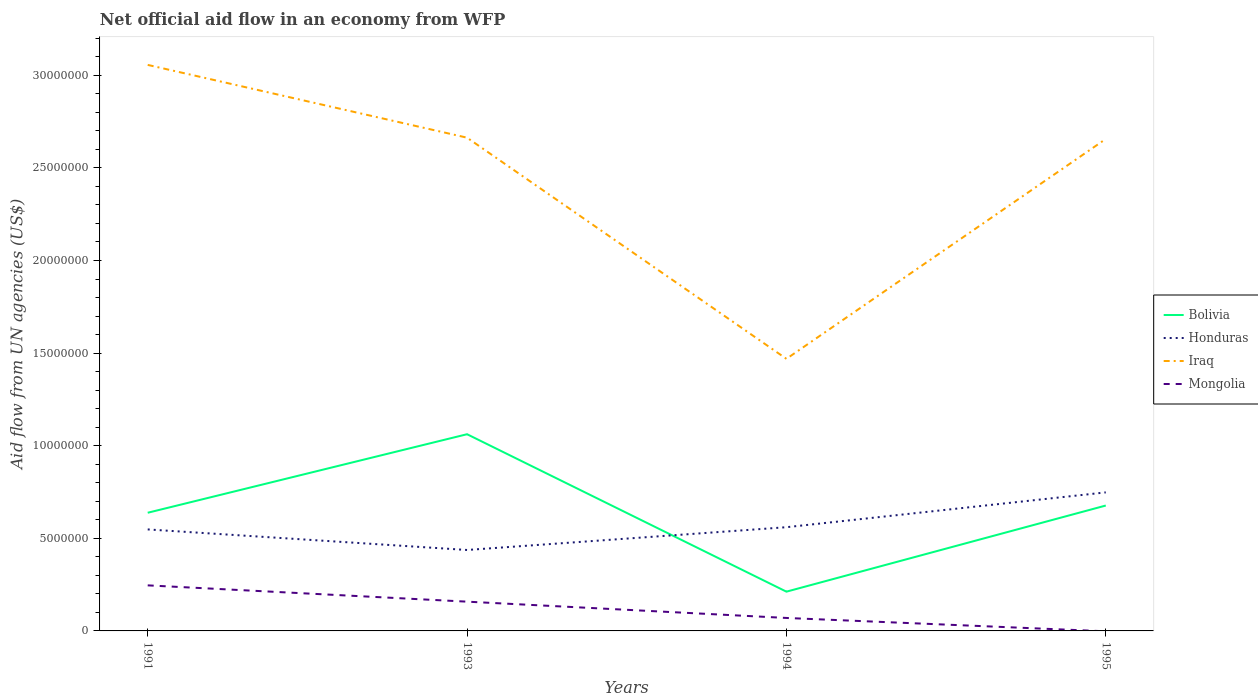Is the number of lines equal to the number of legend labels?
Make the answer very short. No. Across all years, what is the maximum net official aid flow in Iraq?
Ensure brevity in your answer.  1.47e+07. What is the total net official aid flow in Bolivia in the graph?
Provide a short and direct response. -4.24e+06. What is the difference between the highest and the second highest net official aid flow in Honduras?
Give a very brief answer. 3.11e+06. What is the difference between the highest and the lowest net official aid flow in Bolivia?
Ensure brevity in your answer.  2. What is the difference between two consecutive major ticks on the Y-axis?
Offer a terse response. 5.00e+06. Are the values on the major ticks of Y-axis written in scientific E-notation?
Keep it short and to the point. No. Does the graph contain grids?
Your response must be concise. No. How many legend labels are there?
Your answer should be compact. 4. What is the title of the graph?
Make the answer very short. Net official aid flow in an economy from WFP. What is the label or title of the Y-axis?
Make the answer very short. Aid flow from UN agencies (US$). What is the Aid flow from UN agencies (US$) in Bolivia in 1991?
Offer a terse response. 6.38e+06. What is the Aid flow from UN agencies (US$) in Honduras in 1991?
Provide a short and direct response. 5.48e+06. What is the Aid flow from UN agencies (US$) in Iraq in 1991?
Make the answer very short. 3.06e+07. What is the Aid flow from UN agencies (US$) of Mongolia in 1991?
Provide a short and direct response. 2.46e+06. What is the Aid flow from UN agencies (US$) in Bolivia in 1993?
Your answer should be compact. 1.06e+07. What is the Aid flow from UN agencies (US$) of Honduras in 1993?
Make the answer very short. 4.37e+06. What is the Aid flow from UN agencies (US$) in Iraq in 1993?
Give a very brief answer. 2.66e+07. What is the Aid flow from UN agencies (US$) of Mongolia in 1993?
Provide a short and direct response. 1.58e+06. What is the Aid flow from UN agencies (US$) in Bolivia in 1994?
Your answer should be compact. 2.12e+06. What is the Aid flow from UN agencies (US$) of Honduras in 1994?
Offer a terse response. 5.60e+06. What is the Aid flow from UN agencies (US$) of Iraq in 1994?
Ensure brevity in your answer.  1.47e+07. What is the Aid flow from UN agencies (US$) in Bolivia in 1995?
Provide a short and direct response. 6.77e+06. What is the Aid flow from UN agencies (US$) of Honduras in 1995?
Provide a succinct answer. 7.48e+06. What is the Aid flow from UN agencies (US$) in Iraq in 1995?
Your response must be concise. 2.66e+07. What is the Aid flow from UN agencies (US$) of Mongolia in 1995?
Offer a very short reply. 0. Across all years, what is the maximum Aid flow from UN agencies (US$) in Bolivia?
Your response must be concise. 1.06e+07. Across all years, what is the maximum Aid flow from UN agencies (US$) of Honduras?
Offer a terse response. 7.48e+06. Across all years, what is the maximum Aid flow from UN agencies (US$) of Iraq?
Ensure brevity in your answer.  3.06e+07. Across all years, what is the maximum Aid flow from UN agencies (US$) of Mongolia?
Offer a terse response. 2.46e+06. Across all years, what is the minimum Aid flow from UN agencies (US$) of Bolivia?
Your answer should be compact. 2.12e+06. Across all years, what is the minimum Aid flow from UN agencies (US$) of Honduras?
Provide a short and direct response. 4.37e+06. Across all years, what is the minimum Aid flow from UN agencies (US$) of Iraq?
Provide a short and direct response. 1.47e+07. Across all years, what is the minimum Aid flow from UN agencies (US$) of Mongolia?
Keep it short and to the point. 0. What is the total Aid flow from UN agencies (US$) in Bolivia in the graph?
Offer a very short reply. 2.59e+07. What is the total Aid flow from UN agencies (US$) in Honduras in the graph?
Provide a short and direct response. 2.29e+07. What is the total Aid flow from UN agencies (US$) in Iraq in the graph?
Provide a short and direct response. 9.84e+07. What is the total Aid flow from UN agencies (US$) of Mongolia in the graph?
Offer a very short reply. 4.74e+06. What is the difference between the Aid flow from UN agencies (US$) of Bolivia in 1991 and that in 1993?
Keep it short and to the point. -4.24e+06. What is the difference between the Aid flow from UN agencies (US$) of Honduras in 1991 and that in 1993?
Offer a terse response. 1.11e+06. What is the difference between the Aid flow from UN agencies (US$) of Iraq in 1991 and that in 1993?
Your response must be concise. 3.93e+06. What is the difference between the Aid flow from UN agencies (US$) in Mongolia in 1991 and that in 1993?
Make the answer very short. 8.80e+05. What is the difference between the Aid flow from UN agencies (US$) of Bolivia in 1991 and that in 1994?
Your answer should be compact. 4.26e+06. What is the difference between the Aid flow from UN agencies (US$) of Honduras in 1991 and that in 1994?
Your answer should be compact. -1.20e+05. What is the difference between the Aid flow from UN agencies (US$) of Iraq in 1991 and that in 1994?
Ensure brevity in your answer.  1.59e+07. What is the difference between the Aid flow from UN agencies (US$) in Mongolia in 1991 and that in 1994?
Offer a very short reply. 1.76e+06. What is the difference between the Aid flow from UN agencies (US$) of Bolivia in 1991 and that in 1995?
Your answer should be very brief. -3.90e+05. What is the difference between the Aid flow from UN agencies (US$) in Honduras in 1991 and that in 1995?
Provide a short and direct response. -2.00e+06. What is the difference between the Aid flow from UN agencies (US$) in Iraq in 1991 and that in 1995?
Provide a short and direct response. 4.00e+06. What is the difference between the Aid flow from UN agencies (US$) in Bolivia in 1993 and that in 1994?
Give a very brief answer. 8.50e+06. What is the difference between the Aid flow from UN agencies (US$) of Honduras in 1993 and that in 1994?
Your answer should be compact. -1.23e+06. What is the difference between the Aid flow from UN agencies (US$) in Iraq in 1993 and that in 1994?
Provide a succinct answer. 1.19e+07. What is the difference between the Aid flow from UN agencies (US$) of Mongolia in 1993 and that in 1994?
Make the answer very short. 8.80e+05. What is the difference between the Aid flow from UN agencies (US$) in Bolivia in 1993 and that in 1995?
Make the answer very short. 3.85e+06. What is the difference between the Aid flow from UN agencies (US$) in Honduras in 1993 and that in 1995?
Your response must be concise. -3.11e+06. What is the difference between the Aid flow from UN agencies (US$) of Iraq in 1993 and that in 1995?
Your response must be concise. 7.00e+04. What is the difference between the Aid flow from UN agencies (US$) in Bolivia in 1994 and that in 1995?
Offer a very short reply. -4.65e+06. What is the difference between the Aid flow from UN agencies (US$) of Honduras in 1994 and that in 1995?
Give a very brief answer. -1.88e+06. What is the difference between the Aid flow from UN agencies (US$) in Iraq in 1994 and that in 1995?
Offer a terse response. -1.19e+07. What is the difference between the Aid flow from UN agencies (US$) in Bolivia in 1991 and the Aid flow from UN agencies (US$) in Honduras in 1993?
Provide a succinct answer. 2.01e+06. What is the difference between the Aid flow from UN agencies (US$) in Bolivia in 1991 and the Aid flow from UN agencies (US$) in Iraq in 1993?
Provide a short and direct response. -2.02e+07. What is the difference between the Aid flow from UN agencies (US$) of Bolivia in 1991 and the Aid flow from UN agencies (US$) of Mongolia in 1993?
Offer a terse response. 4.80e+06. What is the difference between the Aid flow from UN agencies (US$) of Honduras in 1991 and the Aid flow from UN agencies (US$) of Iraq in 1993?
Your response must be concise. -2.12e+07. What is the difference between the Aid flow from UN agencies (US$) of Honduras in 1991 and the Aid flow from UN agencies (US$) of Mongolia in 1993?
Offer a very short reply. 3.90e+06. What is the difference between the Aid flow from UN agencies (US$) in Iraq in 1991 and the Aid flow from UN agencies (US$) in Mongolia in 1993?
Your answer should be compact. 2.90e+07. What is the difference between the Aid flow from UN agencies (US$) in Bolivia in 1991 and the Aid flow from UN agencies (US$) in Honduras in 1994?
Make the answer very short. 7.80e+05. What is the difference between the Aid flow from UN agencies (US$) of Bolivia in 1991 and the Aid flow from UN agencies (US$) of Iraq in 1994?
Provide a succinct answer. -8.31e+06. What is the difference between the Aid flow from UN agencies (US$) of Bolivia in 1991 and the Aid flow from UN agencies (US$) of Mongolia in 1994?
Offer a terse response. 5.68e+06. What is the difference between the Aid flow from UN agencies (US$) in Honduras in 1991 and the Aid flow from UN agencies (US$) in Iraq in 1994?
Offer a very short reply. -9.21e+06. What is the difference between the Aid flow from UN agencies (US$) of Honduras in 1991 and the Aid flow from UN agencies (US$) of Mongolia in 1994?
Offer a very short reply. 4.78e+06. What is the difference between the Aid flow from UN agencies (US$) in Iraq in 1991 and the Aid flow from UN agencies (US$) in Mongolia in 1994?
Ensure brevity in your answer.  2.99e+07. What is the difference between the Aid flow from UN agencies (US$) of Bolivia in 1991 and the Aid flow from UN agencies (US$) of Honduras in 1995?
Offer a very short reply. -1.10e+06. What is the difference between the Aid flow from UN agencies (US$) in Bolivia in 1991 and the Aid flow from UN agencies (US$) in Iraq in 1995?
Keep it short and to the point. -2.02e+07. What is the difference between the Aid flow from UN agencies (US$) in Honduras in 1991 and the Aid flow from UN agencies (US$) in Iraq in 1995?
Your answer should be compact. -2.11e+07. What is the difference between the Aid flow from UN agencies (US$) in Bolivia in 1993 and the Aid flow from UN agencies (US$) in Honduras in 1994?
Offer a very short reply. 5.02e+06. What is the difference between the Aid flow from UN agencies (US$) in Bolivia in 1993 and the Aid flow from UN agencies (US$) in Iraq in 1994?
Make the answer very short. -4.07e+06. What is the difference between the Aid flow from UN agencies (US$) in Bolivia in 1993 and the Aid flow from UN agencies (US$) in Mongolia in 1994?
Ensure brevity in your answer.  9.92e+06. What is the difference between the Aid flow from UN agencies (US$) of Honduras in 1993 and the Aid flow from UN agencies (US$) of Iraq in 1994?
Make the answer very short. -1.03e+07. What is the difference between the Aid flow from UN agencies (US$) in Honduras in 1993 and the Aid flow from UN agencies (US$) in Mongolia in 1994?
Ensure brevity in your answer.  3.67e+06. What is the difference between the Aid flow from UN agencies (US$) in Iraq in 1993 and the Aid flow from UN agencies (US$) in Mongolia in 1994?
Offer a very short reply. 2.59e+07. What is the difference between the Aid flow from UN agencies (US$) in Bolivia in 1993 and the Aid flow from UN agencies (US$) in Honduras in 1995?
Offer a terse response. 3.14e+06. What is the difference between the Aid flow from UN agencies (US$) of Bolivia in 1993 and the Aid flow from UN agencies (US$) of Iraq in 1995?
Offer a very short reply. -1.59e+07. What is the difference between the Aid flow from UN agencies (US$) of Honduras in 1993 and the Aid flow from UN agencies (US$) of Iraq in 1995?
Provide a succinct answer. -2.22e+07. What is the difference between the Aid flow from UN agencies (US$) in Bolivia in 1994 and the Aid flow from UN agencies (US$) in Honduras in 1995?
Ensure brevity in your answer.  -5.36e+06. What is the difference between the Aid flow from UN agencies (US$) in Bolivia in 1994 and the Aid flow from UN agencies (US$) in Iraq in 1995?
Give a very brief answer. -2.44e+07. What is the difference between the Aid flow from UN agencies (US$) in Honduras in 1994 and the Aid flow from UN agencies (US$) in Iraq in 1995?
Make the answer very short. -2.10e+07. What is the average Aid flow from UN agencies (US$) of Bolivia per year?
Offer a very short reply. 6.47e+06. What is the average Aid flow from UN agencies (US$) in Honduras per year?
Provide a succinct answer. 5.73e+06. What is the average Aid flow from UN agencies (US$) of Iraq per year?
Your answer should be compact. 2.46e+07. What is the average Aid flow from UN agencies (US$) in Mongolia per year?
Provide a succinct answer. 1.18e+06. In the year 1991, what is the difference between the Aid flow from UN agencies (US$) of Bolivia and Aid flow from UN agencies (US$) of Honduras?
Make the answer very short. 9.00e+05. In the year 1991, what is the difference between the Aid flow from UN agencies (US$) of Bolivia and Aid flow from UN agencies (US$) of Iraq?
Keep it short and to the point. -2.42e+07. In the year 1991, what is the difference between the Aid flow from UN agencies (US$) of Bolivia and Aid flow from UN agencies (US$) of Mongolia?
Provide a short and direct response. 3.92e+06. In the year 1991, what is the difference between the Aid flow from UN agencies (US$) of Honduras and Aid flow from UN agencies (US$) of Iraq?
Ensure brevity in your answer.  -2.51e+07. In the year 1991, what is the difference between the Aid flow from UN agencies (US$) in Honduras and Aid flow from UN agencies (US$) in Mongolia?
Offer a terse response. 3.02e+06. In the year 1991, what is the difference between the Aid flow from UN agencies (US$) in Iraq and Aid flow from UN agencies (US$) in Mongolia?
Provide a short and direct response. 2.81e+07. In the year 1993, what is the difference between the Aid flow from UN agencies (US$) of Bolivia and Aid flow from UN agencies (US$) of Honduras?
Your answer should be very brief. 6.25e+06. In the year 1993, what is the difference between the Aid flow from UN agencies (US$) of Bolivia and Aid flow from UN agencies (US$) of Iraq?
Provide a short and direct response. -1.60e+07. In the year 1993, what is the difference between the Aid flow from UN agencies (US$) of Bolivia and Aid flow from UN agencies (US$) of Mongolia?
Keep it short and to the point. 9.04e+06. In the year 1993, what is the difference between the Aid flow from UN agencies (US$) in Honduras and Aid flow from UN agencies (US$) in Iraq?
Provide a short and direct response. -2.23e+07. In the year 1993, what is the difference between the Aid flow from UN agencies (US$) in Honduras and Aid flow from UN agencies (US$) in Mongolia?
Make the answer very short. 2.79e+06. In the year 1993, what is the difference between the Aid flow from UN agencies (US$) of Iraq and Aid flow from UN agencies (US$) of Mongolia?
Your answer should be compact. 2.50e+07. In the year 1994, what is the difference between the Aid flow from UN agencies (US$) in Bolivia and Aid flow from UN agencies (US$) in Honduras?
Ensure brevity in your answer.  -3.48e+06. In the year 1994, what is the difference between the Aid flow from UN agencies (US$) in Bolivia and Aid flow from UN agencies (US$) in Iraq?
Provide a short and direct response. -1.26e+07. In the year 1994, what is the difference between the Aid flow from UN agencies (US$) of Bolivia and Aid flow from UN agencies (US$) of Mongolia?
Offer a terse response. 1.42e+06. In the year 1994, what is the difference between the Aid flow from UN agencies (US$) in Honduras and Aid flow from UN agencies (US$) in Iraq?
Your answer should be very brief. -9.09e+06. In the year 1994, what is the difference between the Aid flow from UN agencies (US$) in Honduras and Aid flow from UN agencies (US$) in Mongolia?
Make the answer very short. 4.90e+06. In the year 1994, what is the difference between the Aid flow from UN agencies (US$) in Iraq and Aid flow from UN agencies (US$) in Mongolia?
Keep it short and to the point. 1.40e+07. In the year 1995, what is the difference between the Aid flow from UN agencies (US$) of Bolivia and Aid flow from UN agencies (US$) of Honduras?
Make the answer very short. -7.10e+05. In the year 1995, what is the difference between the Aid flow from UN agencies (US$) of Bolivia and Aid flow from UN agencies (US$) of Iraq?
Your response must be concise. -1.98e+07. In the year 1995, what is the difference between the Aid flow from UN agencies (US$) in Honduras and Aid flow from UN agencies (US$) in Iraq?
Give a very brief answer. -1.91e+07. What is the ratio of the Aid flow from UN agencies (US$) of Bolivia in 1991 to that in 1993?
Your response must be concise. 0.6. What is the ratio of the Aid flow from UN agencies (US$) in Honduras in 1991 to that in 1993?
Give a very brief answer. 1.25. What is the ratio of the Aid flow from UN agencies (US$) in Iraq in 1991 to that in 1993?
Your answer should be very brief. 1.15. What is the ratio of the Aid flow from UN agencies (US$) in Mongolia in 1991 to that in 1993?
Offer a very short reply. 1.56. What is the ratio of the Aid flow from UN agencies (US$) of Bolivia in 1991 to that in 1994?
Make the answer very short. 3.01. What is the ratio of the Aid flow from UN agencies (US$) of Honduras in 1991 to that in 1994?
Your answer should be compact. 0.98. What is the ratio of the Aid flow from UN agencies (US$) of Iraq in 1991 to that in 1994?
Offer a terse response. 2.08. What is the ratio of the Aid flow from UN agencies (US$) in Mongolia in 1991 to that in 1994?
Make the answer very short. 3.51. What is the ratio of the Aid flow from UN agencies (US$) of Bolivia in 1991 to that in 1995?
Make the answer very short. 0.94. What is the ratio of the Aid flow from UN agencies (US$) of Honduras in 1991 to that in 1995?
Keep it short and to the point. 0.73. What is the ratio of the Aid flow from UN agencies (US$) in Iraq in 1991 to that in 1995?
Offer a terse response. 1.15. What is the ratio of the Aid flow from UN agencies (US$) of Bolivia in 1993 to that in 1994?
Provide a succinct answer. 5.01. What is the ratio of the Aid flow from UN agencies (US$) in Honduras in 1993 to that in 1994?
Give a very brief answer. 0.78. What is the ratio of the Aid flow from UN agencies (US$) of Iraq in 1993 to that in 1994?
Provide a short and direct response. 1.81. What is the ratio of the Aid flow from UN agencies (US$) of Mongolia in 1993 to that in 1994?
Provide a short and direct response. 2.26. What is the ratio of the Aid flow from UN agencies (US$) in Bolivia in 1993 to that in 1995?
Give a very brief answer. 1.57. What is the ratio of the Aid flow from UN agencies (US$) in Honduras in 1993 to that in 1995?
Your response must be concise. 0.58. What is the ratio of the Aid flow from UN agencies (US$) of Iraq in 1993 to that in 1995?
Give a very brief answer. 1. What is the ratio of the Aid flow from UN agencies (US$) of Bolivia in 1994 to that in 1995?
Ensure brevity in your answer.  0.31. What is the ratio of the Aid flow from UN agencies (US$) in Honduras in 1994 to that in 1995?
Your answer should be compact. 0.75. What is the ratio of the Aid flow from UN agencies (US$) of Iraq in 1994 to that in 1995?
Your answer should be very brief. 0.55. What is the difference between the highest and the second highest Aid flow from UN agencies (US$) of Bolivia?
Provide a short and direct response. 3.85e+06. What is the difference between the highest and the second highest Aid flow from UN agencies (US$) of Honduras?
Provide a succinct answer. 1.88e+06. What is the difference between the highest and the second highest Aid flow from UN agencies (US$) in Iraq?
Give a very brief answer. 3.93e+06. What is the difference between the highest and the second highest Aid flow from UN agencies (US$) of Mongolia?
Keep it short and to the point. 8.80e+05. What is the difference between the highest and the lowest Aid flow from UN agencies (US$) in Bolivia?
Provide a succinct answer. 8.50e+06. What is the difference between the highest and the lowest Aid flow from UN agencies (US$) in Honduras?
Your answer should be compact. 3.11e+06. What is the difference between the highest and the lowest Aid flow from UN agencies (US$) in Iraq?
Offer a very short reply. 1.59e+07. What is the difference between the highest and the lowest Aid flow from UN agencies (US$) of Mongolia?
Make the answer very short. 2.46e+06. 